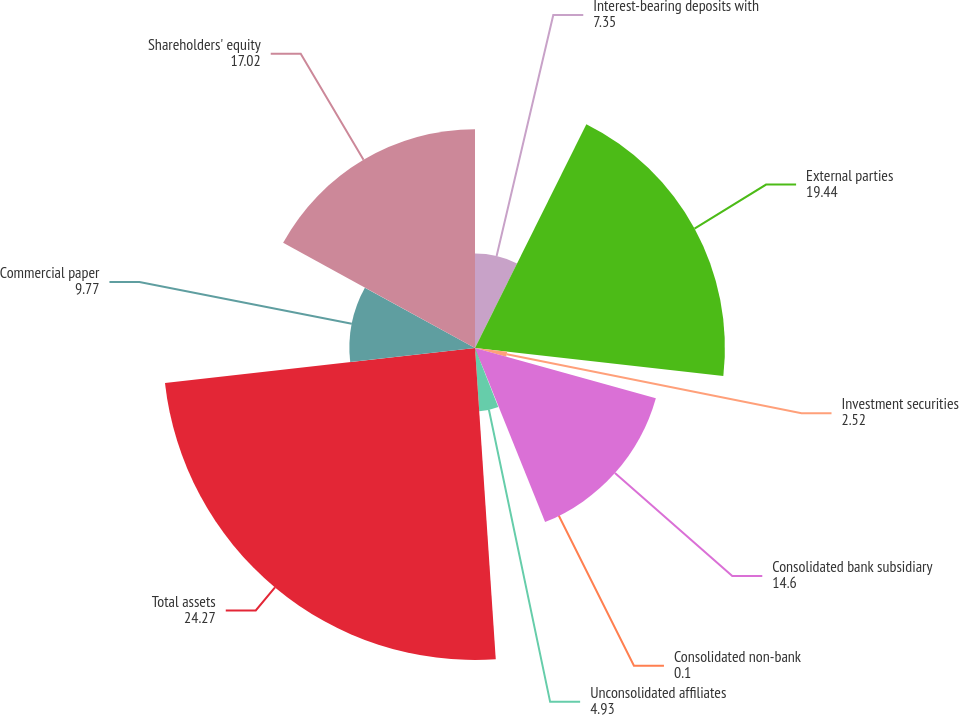Convert chart to OTSL. <chart><loc_0><loc_0><loc_500><loc_500><pie_chart><fcel>Interest-bearing deposits with<fcel>External parties<fcel>Investment securities<fcel>Consolidated bank subsidiary<fcel>Consolidated non-bank<fcel>Unconsolidated affiliates<fcel>Total assets<fcel>Commercial paper<fcel>Shareholders' equity<nl><fcel>7.35%<fcel>19.44%<fcel>2.52%<fcel>14.6%<fcel>0.1%<fcel>4.93%<fcel>24.27%<fcel>9.77%<fcel>17.02%<nl></chart> 